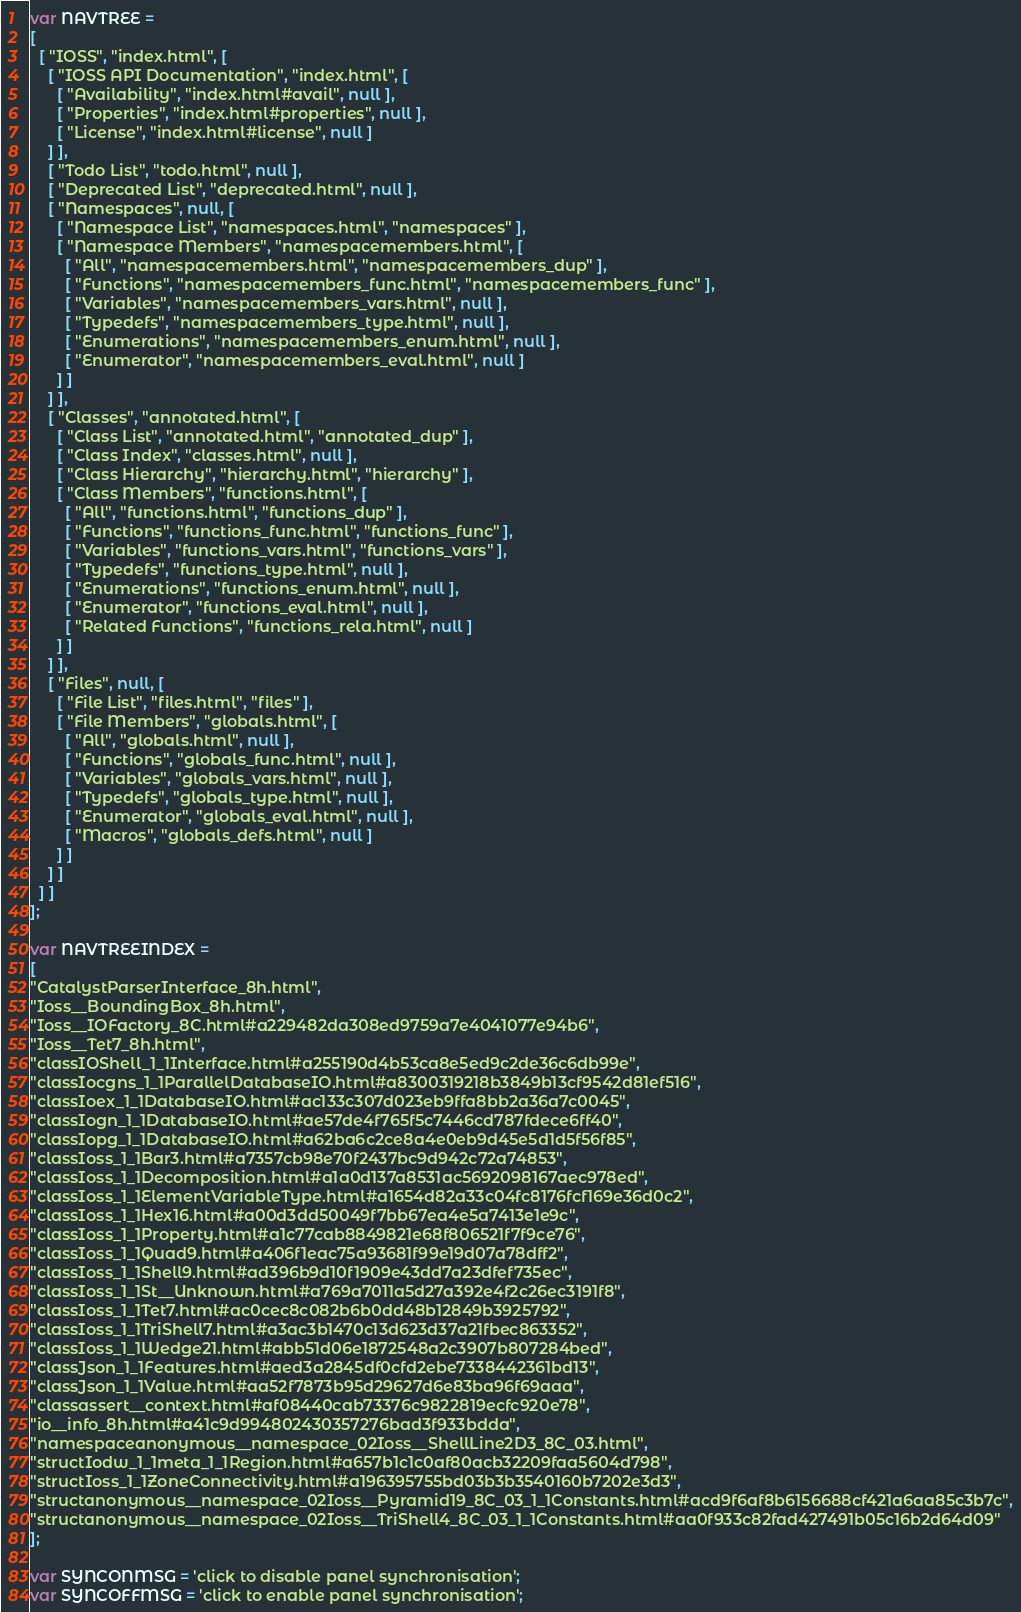<code> <loc_0><loc_0><loc_500><loc_500><_JavaScript_>var NAVTREE =
[
  [ "IOSS", "index.html", [
    [ "IOSS API Documentation", "index.html", [
      [ "Availability", "index.html#avail", null ],
      [ "Properties", "index.html#properties", null ],
      [ "License", "index.html#license", null ]
    ] ],
    [ "Todo List", "todo.html", null ],
    [ "Deprecated List", "deprecated.html", null ],
    [ "Namespaces", null, [
      [ "Namespace List", "namespaces.html", "namespaces" ],
      [ "Namespace Members", "namespacemembers.html", [
        [ "All", "namespacemembers.html", "namespacemembers_dup" ],
        [ "Functions", "namespacemembers_func.html", "namespacemembers_func" ],
        [ "Variables", "namespacemembers_vars.html", null ],
        [ "Typedefs", "namespacemembers_type.html", null ],
        [ "Enumerations", "namespacemembers_enum.html", null ],
        [ "Enumerator", "namespacemembers_eval.html", null ]
      ] ]
    ] ],
    [ "Classes", "annotated.html", [
      [ "Class List", "annotated.html", "annotated_dup" ],
      [ "Class Index", "classes.html", null ],
      [ "Class Hierarchy", "hierarchy.html", "hierarchy" ],
      [ "Class Members", "functions.html", [
        [ "All", "functions.html", "functions_dup" ],
        [ "Functions", "functions_func.html", "functions_func" ],
        [ "Variables", "functions_vars.html", "functions_vars" ],
        [ "Typedefs", "functions_type.html", null ],
        [ "Enumerations", "functions_enum.html", null ],
        [ "Enumerator", "functions_eval.html", null ],
        [ "Related Functions", "functions_rela.html", null ]
      ] ]
    ] ],
    [ "Files", null, [
      [ "File List", "files.html", "files" ],
      [ "File Members", "globals.html", [
        [ "All", "globals.html", null ],
        [ "Functions", "globals_func.html", null ],
        [ "Variables", "globals_vars.html", null ],
        [ "Typedefs", "globals_type.html", null ],
        [ "Enumerator", "globals_eval.html", null ],
        [ "Macros", "globals_defs.html", null ]
      ] ]
    ] ]
  ] ]
];

var NAVTREEINDEX =
[
"CatalystParserInterface_8h.html",
"Ioss__BoundingBox_8h.html",
"Ioss__IOFactory_8C.html#a229482da308ed9759a7e4041077e94b6",
"Ioss__Tet7_8h.html",
"classIOShell_1_1Interface.html#a255190d4b53ca8e5ed9c2de36c6db99e",
"classIocgns_1_1ParallelDatabaseIO.html#a8300319218b3849b13cf9542d81ef516",
"classIoex_1_1DatabaseIO.html#ac133c307d023eb9ffa8bb2a36a7c0045",
"classIogn_1_1DatabaseIO.html#ae57de4f765f5c7446cd787fdece6ff40",
"classIopg_1_1DatabaseIO.html#a62ba6c2ce8a4e0eb9d45e5d1d5f56f85",
"classIoss_1_1Bar3.html#a7357cb98e70f2437bc9d942c72a74853",
"classIoss_1_1Decomposition.html#a1a0d137a8531ac5692098167aec978ed",
"classIoss_1_1ElementVariableType.html#a1654d82a33c04fc8176fcf169e36d0c2",
"classIoss_1_1Hex16.html#a00d3dd50049f7bb67ea4e5a7413e1e9c",
"classIoss_1_1Property.html#a1c77cab8849821e68f806521f7f9ce76",
"classIoss_1_1Quad9.html#a406f1eac75a93681f99e19d07a78dff2",
"classIoss_1_1Shell9.html#ad396b9d10f1909e43dd7a23dfef735ec",
"classIoss_1_1St__Unknown.html#a769a7011a5d27a392e4f2c26ec3191f8",
"classIoss_1_1Tet7.html#ac0cec8c082b6b0dd48b12849b3925792",
"classIoss_1_1TriShell7.html#a3ac3b1470c13d623d37a21fbec863352",
"classIoss_1_1Wedge21.html#abb51d06e1872548a2c3907b807284bed",
"classJson_1_1Features.html#aed3a2845df0cfd2ebe7338442361bd13",
"classJson_1_1Value.html#aa52f7873b95d29627d6e83ba96f69aaa",
"classassert__context.html#af08440cab73376c9822819ecfc920e78",
"io__info_8h.html#a41c9d994802430357276bad3f933bdda",
"namespaceanonymous__namespace_02Ioss__ShellLine2D3_8C_03.html",
"structIodw_1_1meta_1_1Region.html#a657b1c1c0af80acb32209faa5604d798",
"structIoss_1_1ZoneConnectivity.html#a196395755bd03b3b3540160b7202e3d3",
"structanonymous__namespace_02Ioss__Pyramid19_8C_03_1_1Constants.html#acd9f6af8b6156688cf421a6aa85c3b7c",
"structanonymous__namespace_02Ioss__TriShell4_8C_03_1_1Constants.html#aa0f933c82fad427491b05c16b2d64d09"
];

var SYNCONMSG = 'click to disable panel synchronisation';
var SYNCOFFMSG = 'click to enable panel synchronisation';</code> 